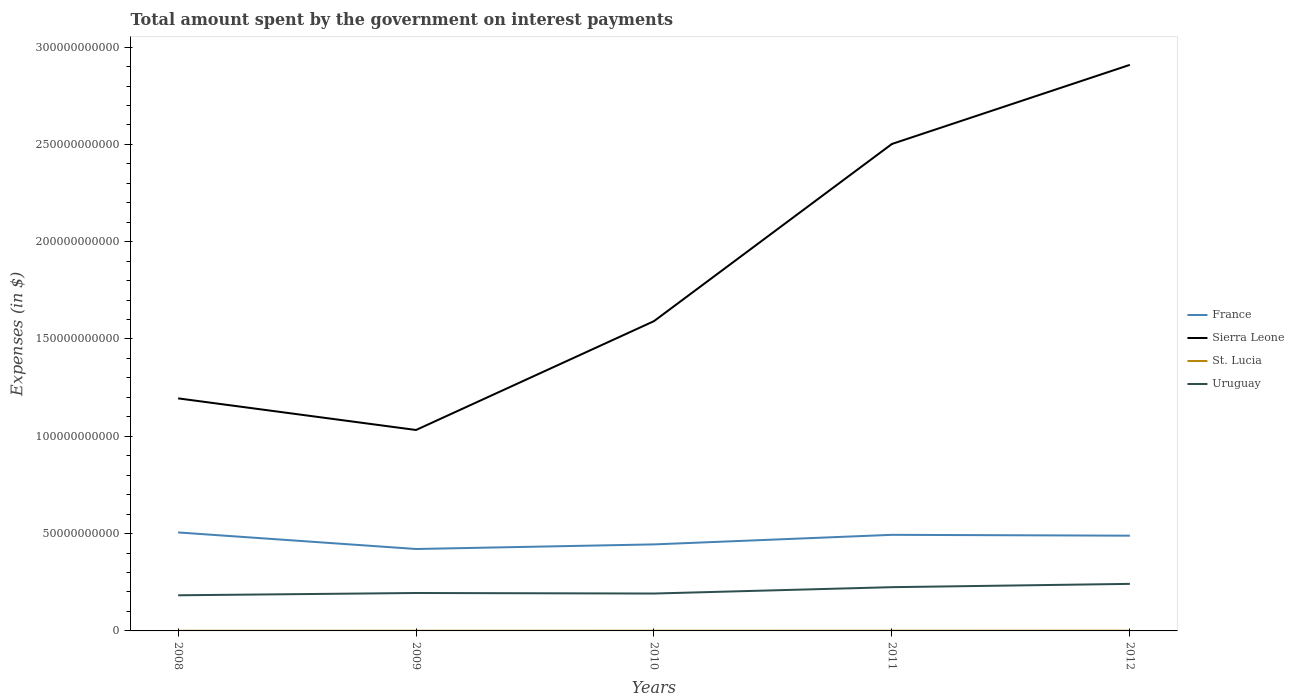Does the line corresponding to St. Lucia intersect with the line corresponding to France?
Offer a very short reply. No. Across all years, what is the maximum amount spent on interest payments by the government in St. Lucia?
Offer a terse response. 7.84e+07. What is the difference between the highest and the second highest amount spent on interest payments by the government in France?
Give a very brief answer. 8.51e+09. Is the amount spent on interest payments by the government in Sierra Leone strictly greater than the amount spent on interest payments by the government in St. Lucia over the years?
Offer a very short reply. No. Does the graph contain any zero values?
Your answer should be compact. No. How many legend labels are there?
Your response must be concise. 4. How are the legend labels stacked?
Offer a very short reply. Vertical. What is the title of the graph?
Provide a succinct answer. Total amount spent by the government on interest payments. What is the label or title of the X-axis?
Provide a short and direct response. Years. What is the label or title of the Y-axis?
Offer a very short reply. Expenses (in $). What is the Expenses (in $) in France in 2008?
Ensure brevity in your answer.  5.06e+1. What is the Expenses (in $) of Sierra Leone in 2008?
Offer a terse response. 1.19e+11. What is the Expenses (in $) in St. Lucia in 2008?
Provide a short and direct response. 7.84e+07. What is the Expenses (in $) of Uruguay in 2008?
Offer a very short reply. 1.83e+1. What is the Expenses (in $) in France in 2009?
Ensure brevity in your answer.  4.21e+1. What is the Expenses (in $) of Sierra Leone in 2009?
Your response must be concise. 1.03e+11. What is the Expenses (in $) of St. Lucia in 2009?
Your answer should be very brief. 8.98e+07. What is the Expenses (in $) in Uruguay in 2009?
Offer a terse response. 1.95e+1. What is the Expenses (in $) in France in 2010?
Make the answer very short. 4.45e+1. What is the Expenses (in $) in Sierra Leone in 2010?
Offer a terse response. 1.59e+11. What is the Expenses (in $) of St. Lucia in 2010?
Provide a short and direct response. 9.28e+07. What is the Expenses (in $) in Uruguay in 2010?
Your response must be concise. 1.92e+1. What is the Expenses (in $) of France in 2011?
Provide a succinct answer. 4.94e+1. What is the Expenses (in $) of Sierra Leone in 2011?
Offer a very short reply. 2.50e+11. What is the Expenses (in $) in St. Lucia in 2011?
Your response must be concise. 1.00e+08. What is the Expenses (in $) in Uruguay in 2011?
Your answer should be very brief. 2.25e+1. What is the Expenses (in $) in France in 2012?
Offer a very short reply. 4.89e+1. What is the Expenses (in $) in Sierra Leone in 2012?
Your response must be concise. 2.91e+11. What is the Expenses (in $) in St. Lucia in 2012?
Give a very brief answer. 1.23e+08. What is the Expenses (in $) of Uruguay in 2012?
Ensure brevity in your answer.  2.42e+1. Across all years, what is the maximum Expenses (in $) in France?
Your answer should be very brief. 5.06e+1. Across all years, what is the maximum Expenses (in $) of Sierra Leone?
Offer a very short reply. 2.91e+11. Across all years, what is the maximum Expenses (in $) in St. Lucia?
Your answer should be compact. 1.23e+08. Across all years, what is the maximum Expenses (in $) in Uruguay?
Ensure brevity in your answer.  2.42e+1. Across all years, what is the minimum Expenses (in $) of France?
Your response must be concise. 4.21e+1. Across all years, what is the minimum Expenses (in $) of Sierra Leone?
Give a very brief answer. 1.03e+11. Across all years, what is the minimum Expenses (in $) in St. Lucia?
Your answer should be very brief. 7.84e+07. Across all years, what is the minimum Expenses (in $) in Uruguay?
Give a very brief answer. 1.83e+1. What is the total Expenses (in $) in France in the graph?
Ensure brevity in your answer.  2.35e+11. What is the total Expenses (in $) of Sierra Leone in the graph?
Offer a terse response. 9.23e+11. What is the total Expenses (in $) of St. Lucia in the graph?
Provide a succinct answer. 4.84e+08. What is the total Expenses (in $) of Uruguay in the graph?
Provide a short and direct response. 1.04e+11. What is the difference between the Expenses (in $) in France in 2008 and that in 2009?
Your response must be concise. 8.51e+09. What is the difference between the Expenses (in $) of Sierra Leone in 2008 and that in 2009?
Your answer should be compact. 1.62e+1. What is the difference between the Expenses (in $) of St. Lucia in 2008 and that in 2009?
Provide a short and direct response. -1.14e+07. What is the difference between the Expenses (in $) of Uruguay in 2008 and that in 2009?
Your answer should be compact. -1.18e+09. What is the difference between the Expenses (in $) in France in 2008 and that in 2010?
Make the answer very short. 6.15e+09. What is the difference between the Expenses (in $) in Sierra Leone in 2008 and that in 2010?
Provide a short and direct response. -3.97e+1. What is the difference between the Expenses (in $) of St. Lucia in 2008 and that in 2010?
Provide a succinct answer. -1.44e+07. What is the difference between the Expenses (in $) of Uruguay in 2008 and that in 2010?
Ensure brevity in your answer.  -9.02e+08. What is the difference between the Expenses (in $) of France in 2008 and that in 2011?
Your answer should be very brief. 1.23e+09. What is the difference between the Expenses (in $) in Sierra Leone in 2008 and that in 2011?
Keep it short and to the point. -1.31e+11. What is the difference between the Expenses (in $) of St. Lucia in 2008 and that in 2011?
Offer a very short reply. -2.18e+07. What is the difference between the Expenses (in $) of Uruguay in 2008 and that in 2011?
Ensure brevity in your answer.  -4.17e+09. What is the difference between the Expenses (in $) in France in 2008 and that in 2012?
Offer a terse response. 1.66e+09. What is the difference between the Expenses (in $) of Sierra Leone in 2008 and that in 2012?
Your answer should be very brief. -1.71e+11. What is the difference between the Expenses (in $) in St. Lucia in 2008 and that in 2012?
Your response must be concise. -4.48e+07. What is the difference between the Expenses (in $) of Uruguay in 2008 and that in 2012?
Your response must be concise. -5.86e+09. What is the difference between the Expenses (in $) of France in 2009 and that in 2010?
Make the answer very short. -2.37e+09. What is the difference between the Expenses (in $) in Sierra Leone in 2009 and that in 2010?
Provide a short and direct response. -5.59e+1. What is the difference between the Expenses (in $) in Uruguay in 2009 and that in 2010?
Ensure brevity in your answer.  2.75e+08. What is the difference between the Expenses (in $) of France in 2009 and that in 2011?
Offer a terse response. -7.29e+09. What is the difference between the Expenses (in $) of Sierra Leone in 2009 and that in 2011?
Your answer should be compact. -1.47e+11. What is the difference between the Expenses (in $) of St. Lucia in 2009 and that in 2011?
Provide a short and direct response. -1.04e+07. What is the difference between the Expenses (in $) of Uruguay in 2009 and that in 2011?
Offer a terse response. -2.99e+09. What is the difference between the Expenses (in $) in France in 2009 and that in 2012?
Provide a succinct answer. -6.85e+09. What is the difference between the Expenses (in $) in Sierra Leone in 2009 and that in 2012?
Provide a succinct answer. -1.88e+11. What is the difference between the Expenses (in $) in St. Lucia in 2009 and that in 2012?
Give a very brief answer. -3.34e+07. What is the difference between the Expenses (in $) of Uruguay in 2009 and that in 2012?
Give a very brief answer. -4.69e+09. What is the difference between the Expenses (in $) in France in 2010 and that in 2011?
Your answer should be very brief. -4.92e+09. What is the difference between the Expenses (in $) in Sierra Leone in 2010 and that in 2011?
Your answer should be compact. -9.10e+1. What is the difference between the Expenses (in $) in St. Lucia in 2010 and that in 2011?
Ensure brevity in your answer.  -7.40e+06. What is the difference between the Expenses (in $) in Uruguay in 2010 and that in 2011?
Provide a short and direct response. -3.26e+09. What is the difference between the Expenses (in $) of France in 2010 and that in 2012?
Provide a succinct answer. -4.48e+09. What is the difference between the Expenses (in $) in Sierra Leone in 2010 and that in 2012?
Your response must be concise. -1.32e+11. What is the difference between the Expenses (in $) in St. Lucia in 2010 and that in 2012?
Your answer should be compact. -3.04e+07. What is the difference between the Expenses (in $) of Uruguay in 2010 and that in 2012?
Keep it short and to the point. -4.96e+09. What is the difference between the Expenses (in $) in France in 2011 and that in 2012?
Give a very brief answer. 4.36e+08. What is the difference between the Expenses (in $) of Sierra Leone in 2011 and that in 2012?
Offer a terse response. -4.06e+1. What is the difference between the Expenses (in $) in St. Lucia in 2011 and that in 2012?
Your response must be concise. -2.30e+07. What is the difference between the Expenses (in $) in Uruguay in 2011 and that in 2012?
Give a very brief answer. -1.70e+09. What is the difference between the Expenses (in $) of France in 2008 and the Expenses (in $) of Sierra Leone in 2009?
Ensure brevity in your answer.  -5.26e+1. What is the difference between the Expenses (in $) of France in 2008 and the Expenses (in $) of St. Lucia in 2009?
Keep it short and to the point. 5.05e+1. What is the difference between the Expenses (in $) in France in 2008 and the Expenses (in $) in Uruguay in 2009?
Provide a short and direct response. 3.11e+1. What is the difference between the Expenses (in $) in Sierra Leone in 2008 and the Expenses (in $) in St. Lucia in 2009?
Ensure brevity in your answer.  1.19e+11. What is the difference between the Expenses (in $) of Sierra Leone in 2008 and the Expenses (in $) of Uruguay in 2009?
Offer a very short reply. 1.00e+11. What is the difference between the Expenses (in $) in St. Lucia in 2008 and the Expenses (in $) in Uruguay in 2009?
Offer a terse response. -1.94e+1. What is the difference between the Expenses (in $) in France in 2008 and the Expenses (in $) in Sierra Leone in 2010?
Your response must be concise. -1.09e+11. What is the difference between the Expenses (in $) in France in 2008 and the Expenses (in $) in St. Lucia in 2010?
Provide a succinct answer. 5.05e+1. What is the difference between the Expenses (in $) in France in 2008 and the Expenses (in $) in Uruguay in 2010?
Ensure brevity in your answer.  3.14e+1. What is the difference between the Expenses (in $) of Sierra Leone in 2008 and the Expenses (in $) of St. Lucia in 2010?
Your response must be concise. 1.19e+11. What is the difference between the Expenses (in $) of Sierra Leone in 2008 and the Expenses (in $) of Uruguay in 2010?
Make the answer very short. 1.00e+11. What is the difference between the Expenses (in $) in St. Lucia in 2008 and the Expenses (in $) in Uruguay in 2010?
Offer a terse response. -1.91e+1. What is the difference between the Expenses (in $) in France in 2008 and the Expenses (in $) in Sierra Leone in 2011?
Offer a very short reply. -2.00e+11. What is the difference between the Expenses (in $) in France in 2008 and the Expenses (in $) in St. Lucia in 2011?
Keep it short and to the point. 5.05e+1. What is the difference between the Expenses (in $) in France in 2008 and the Expenses (in $) in Uruguay in 2011?
Keep it short and to the point. 2.81e+1. What is the difference between the Expenses (in $) of Sierra Leone in 2008 and the Expenses (in $) of St. Lucia in 2011?
Your answer should be very brief. 1.19e+11. What is the difference between the Expenses (in $) of Sierra Leone in 2008 and the Expenses (in $) of Uruguay in 2011?
Make the answer very short. 9.70e+1. What is the difference between the Expenses (in $) of St. Lucia in 2008 and the Expenses (in $) of Uruguay in 2011?
Offer a very short reply. -2.24e+1. What is the difference between the Expenses (in $) of France in 2008 and the Expenses (in $) of Sierra Leone in 2012?
Give a very brief answer. -2.40e+11. What is the difference between the Expenses (in $) in France in 2008 and the Expenses (in $) in St. Lucia in 2012?
Provide a succinct answer. 5.05e+1. What is the difference between the Expenses (in $) of France in 2008 and the Expenses (in $) of Uruguay in 2012?
Your answer should be compact. 2.64e+1. What is the difference between the Expenses (in $) in Sierra Leone in 2008 and the Expenses (in $) in St. Lucia in 2012?
Keep it short and to the point. 1.19e+11. What is the difference between the Expenses (in $) of Sierra Leone in 2008 and the Expenses (in $) of Uruguay in 2012?
Make the answer very short. 9.53e+1. What is the difference between the Expenses (in $) in St. Lucia in 2008 and the Expenses (in $) in Uruguay in 2012?
Keep it short and to the point. -2.41e+1. What is the difference between the Expenses (in $) in France in 2009 and the Expenses (in $) in Sierra Leone in 2010?
Provide a succinct answer. -1.17e+11. What is the difference between the Expenses (in $) of France in 2009 and the Expenses (in $) of St. Lucia in 2010?
Offer a terse response. 4.20e+1. What is the difference between the Expenses (in $) in France in 2009 and the Expenses (in $) in Uruguay in 2010?
Offer a very short reply. 2.29e+1. What is the difference between the Expenses (in $) in Sierra Leone in 2009 and the Expenses (in $) in St. Lucia in 2010?
Your response must be concise. 1.03e+11. What is the difference between the Expenses (in $) in Sierra Leone in 2009 and the Expenses (in $) in Uruguay in 2010?
Offer a terse response. 8.40e+1. What is the difference between the Expenses (in $) in St. Lucia in 2009 and the Expenses (in $) in Uruguay in 2010?
Provide a short and direct response. -1.91e+1. What is the difference between the Expenses (in $) in France in 2009 and the Expenses (in $) in Sierra Leone in 2011?
Provide a succinct answer. -2.08e+11. What is the difference between the Expenses (in $) in France in 2009 and the Expenses (in $) in St. Lucia in 2011?
Ensure brevity in your answer.  4.20e+1. What is the difference between the Expenses (in $) of France in 2009 and the Expenses (in $) of Uruguay in 2011?
Provide a short and direct response. 1.96e+1. What is the difference between the Expenses (in $) in Sierra Leone in 2009 and the Expenses (in $) in St. Lucia in 2011?
Your response must be concise. 1.03e+11. What is the difference between the Expenses (in $) of Sierra Leone in 2009 and the Expenses (in $) of Uruguay in 2011?
Ensure brevity in your answer.  8.08e+1. What is the difference between the Expenses (in $) of St. Lucia in 2009 and the Expenses (in $) of Uruguay in 2011?
Your answer should be very brief. -2.24e+1. What is the difference between the Expenses (in $) in France in 2009 and the Expenses (in $) in Sierra Leone in 2012?
Your response must be concise. -2.49e+11. What is the difference between the Expenses (in $) in France in 2009 and the Expenses (in $) in St. Lucia in 2012?
Provide a succinct answer. 4.20e+1. What is the difference between the Expenses (in $) of France in 2009 and the Expenses (in $) of Uruguay in 2012?
Offer a very short reply. 1.79e+1. What is the difference between the Expenses (in $) of Sierra Leone in 2009 and the Expenses (in $) of St. Lucia in 2012?
Your answer should be compact. 1.03e+11. What is the difference between the Expenses (in $) in Sierra Leone in 2009 and the Expenses (in $) in Uruguay in 2012?
Your answer should be compact. 7.91e+1. What is the difference between the Expenses (in $) in St. Lucia in 2009 and the Expenses (in $) in Uruguay in 2012?
Your answer should be compact. -2.41e+1. What is the difference between the Expenses (in $) in France in 2010 and the Expenses (in $) in Sierra Leone in 2011?
Your answer should be compact. -2.06e+11. What is the difference between the Expenses (in $) of France in 2010 and the Expenses (in $) of St. Lucia in 2011?
Your answer should be compact. 4.44e+1. What is the difference between the Expenses (in $) of France in 2010 and the Expenses (in $) of Uruguay in 2011?
Make the answer very short. 2.20e+1. What is the difference between the Expenses (in $) in Sierra Leone in 2010 and the Expenses (in $) in St. Lucia in 2011?
Your answer should be very brief. 1.59e+11. What is the difference between the Expenses (in $) in Sierra Leone in 2010 and the Expenses (in $) in Uruguay in 2011?
Your answer should be very brief. 1.37e+11. What is the difference between the Expenses (in $) of St. Lucia in 2010 and the Expenses (in $) of Uruguay in 2011?
Your answer should be very brief. -2.24e+1. What is the difference between the Expenses (in $) in France in 2010 and the Expenses (in $) in Sierra Leone in 2012?
Your response must be concise. -2.46e+11. What is the difference between the Expenses (in $) in France in 2010 and the Expenses (in $) in St. Lucia in 2012?
Offer a terse response. 4.43e+1. What is the difference between the Expenses (in $) in France in 2010 and the Expenses (in $) in Uruguay in 2012?
Offer a very short reply. 2.03e+1. What is the difference between the Expenses (in $) in Sierra Leone in 2010 and the Expenses (in $) in St. Lucia in 2012?
Make the answer very short. 1.59e+11. What is the difference between the Expenses (in $) in Sierra Leone in 2010 and the Expenses (in $) in Uruguay in 2012?
Your response must be concise. 1.35e+11. What is the difference between the Expenses (in $) in St. Lucia in 2010 and the Expenses (in $) in Uruguay in 2012?
Provide a short and direct response. -2.41e+1. What is the difference between the Expenses (in $) of France in 2011 and the Expenses (in $) of Sierra Leone in 2012?
Ensure brevity in your answer.  -2.41e+11. What is the difference between the Expenses (in $) of France in 2011 and the Expenses (in $) of St. Lucia in 2012?
Offer a terse response. 4.93e+1. What is the difference between the Expenses (in $) of France in 2011 and the Expenses (in $) of Uruguay in 2012?
Make the answer very short. 2.52e+1. What is the difference between the Expenses (in $) in Sierra Leone in 2011 and the Expenses (in $) in St. Lucia in 2012?
Provide a succinct answer. 2.50e+11. What is the difference between the Expenses (in $) of Sierra Leone in 2011 and the Expenses (in $) of Uruguay in 2012?
Offer a terse response. 2.26e+11. What is the difference between the Expenses (in $) in St. Lucia in 2011 and the Expenses (in $) in Uruguay in 2012?
Your answer should be compact. -2.41e+1. What is the average Expenses (in $) in France per year?
Your answer should be very brief. 4.71e+1. What is the average Expenses (in $) in Sierra Leone per year?
Make the answer very short. 1.85e+11. What is the average Expenses (in $) of St. Lucia per year?
Provide a short and direct response. 9.69e+07. What is the average Expenses (in $) of Uruguay per year?
Make the answer very short. 2.07e+1. In the year 2008, what is the difference between the Expenses (in $) in France and Expenses (in $) in Sierra Leone?
Offer a terse response. -6.89e+1. In the year 2008, what is the difference between the Expenses (in $) of France and Expenses (in $) of St. Lucia?
Give a very brief answer. 5.05e+1. In the year 2008, what is the difference between the Expenses (in $) of France and Expenses (in $) of Uruguay?
Your answer should be very brief. 3.23e+1. In the year 2008, what is the difference between the Expenses (in $) in Sierra Leone and Expenses (in $) in St. Lucia?
Offer a very short reply. 1.19e+11. In the year 2008, what is the difference between the Expenses (in $) in Sierra Leone and Expenses (in $) in Uruguay?
Provide a short and direct response. 1.01e+11. In the year 2008, what is the difference between the Expenses (in $) in St. Lucia and Expenses (in $) in Uruguay?
Make the answer very short. -1.82e+1. In the year 2009, what is the difference between the Expenses (in $) of France and Expenses (in $) of Sierra Leone?
Your response must be concise. -6.12e+1. In the year 2009, what is the difference between the Expenses (in $) of France and Expenses (in $) of St. Lucia?
Your answer should be compact. 4.20e+1. In the year 2009, what is the difference between the Expenses (in $) in France and Expenses (in $) in Uruguay?
Offer a very short reply. 2.26e+1. In the year 2009, what is the difference between the Expenses (in $) in Sierra Leone and Expenses (in $) in St. Lucia?
Offer a terse response. 1.03e+11. In the year 2009, what is the difference between the Expenses (in $) in Sierra Leone and Expenses (in $) in Uruguay?
Your answer should be compact. 8.38e+1. In the year 2009, what is the difference between the Expenses (in $) of St. Lucia and Expenses (in $) of Uruguay?
Make the answer very short. -1.94e+1. In the year 2010, what is the difference between the Expenses (in $) in France and Expenses (in $) in Sierra Leone?
Your answer should be compact. -1.15e+11. In the year 2010, what is the difference between the Expenses (in $) in France and Expenses (in $) in St. Lucia?
Provide a short and direct response. 4.44e+1. In the year 2010, what is the difference between the Expenses (in $) in France and Expenses (in $) in Uruguay?
Keep it short and to the point. 2.52e+1. In the year 2010, what is the difference between the Expenses (in $) in Sierra Leone and Expenses (in $) in St. Lucia?
Offer a very short reply. 1.59e+11. In the year 2010, what is the difference between the Expenses (in $) of Sierra Leone and Expenses (in $) of Uruguay?
Provide a short and direct response. 1.40e+11. In the year 2010, what is the difference between the Expenses (in $) of St. Lucia and Expenses (in $) of Uruguay?
Provide a succinct answer. -1.91e+1. In the year 2011, what is the difference between the Expenses (in $) of France and Expenses (in $) of Sierra Leone?
Offer a very short reply. -2.01e+11. In the year 2011, what is the difference between the Expenses (in $) of France and Expenses (in $) of St. Lucia?
Provide a succinct answer. 4.93e+1. In the year 2011, what is the difference between the Expenses (in $) of France and Expenses (in $) of Uruguay?
Make the answer very short. 2.69e+1. In the year 2011, what is the difference between the Expenses (in $) of Sierra Leone and Expenses (in $) of St. Lucia?
Offer a very short reply. 2.50e+11. In the year 2011, what is the difference between the Expenses (in $) in Sierra Leone and Expenses (in $) in Uruguay?
Your answer should be compact. 2.28e+11. In the year 2011, what is the difference between the Expenses (in $) of St. Lucia and Expenses (in $) of Uruguay?
Keep it short and to the point. -2.24e+1. In the year 2012, what is the difference between the Expenses (in $) in France and Expenses (in $) in Sierra Leone?
Your answer should be compact. -2.42e+11. In the year 2012, what is the difference between the Expenses (in $) of France and Expenses (in $) of St. Lucia?
Provide a short and direct response. 4.88e+1. In the year 2012, what is the difference between the Expenses (in $) of France and Expenses (in $) of Uruguay?
Provide a short and direct response. 2.48e+1. In the year 2012, what is the difference between the Expenses (in $) of Sierra Leone and Expenses (in $) of St. Lucia?
Provide a succinct answer. 2.91e+11. In the year 2012, what is the difference between the Expenses (in $) in Sierra Leone and Expenses (in $) in Uruguay?
Ensure brevity in your answer.  2.67e+11. In the year 2012, what is the difference between the Expenses (in $) in St. Lucia and Expenses (in $) in Uruguay?
Your answer should be very brief. -2.40e+1. What is the ratio of the Expenses (in $) in France in 2008 to that in 2009?
Make the answer very short. 1.2. What is the ratio of the Expenses (in $) in Sierra Leone in 2008 to that in 2009?
Give a very brief answer. 1.16. What is the ratio of the Expenses (in $) of St. Lucia in 2008 to that in 2009?
Your answer should be compact. 0.87. What is the ratio of the Expenses (in $) in Uruguay in 2008 to that in 2009?
Provide a short and direct response. 0.94. What is the ratio of the Expenses (in $) in France in 2008 to that in 2010?
Provide a short and direct response. 1.14. What is the ratio of the Expenses (in $) of Sierra Leone in 2008 to that in 2010?
Ensure brevity in your answer.  0.75. What is the ratio of the Expenses (in $) in St. Lucia in 2008 to that in 2010?
Provide a short and direct response. 0.84. What is the ratio of the Expenses (in $) in Uruguay in 2008 to that in 2010?
Make the answer very short. 0.95. What is the ratio of the Expenses (in $) of France in 2008 to that in 2011?
Your answer should be compact. 1.02. What is the ratio of the Expenses (in $) in Sierra Leone in 2008 to that in 2011?
Give a very brief answer. 0.48. What is the ratio of the Expenses (in $) in St. Lucia in 2008 to that in 2011?
Your answer should be compact. 0.78. What is the ratio of the Expenses (in $) of Uruguay in 2008 to that in 2011?
Keep it short and to the point. 0.81. What is the ratio of the Expenses (in $) of France in 2008 to that in 2012?
Your answer should be compact. 1.03. What is the ratio of the Expenses (in $) of Sierra Leone in 2008 to that in 2012?
Keep it short and to the point. 0.41. What is the ratio of the Expenses (in $) in St. Lucia in 2008 to that in 2012?
Your answer should be compact. 0.64. What is the ratio of the Expenses (in $) of Uruguay in 2008 to that in 2012?
Make the answer very short. 0.76. What is the ratio of the Expenses (in $) in France in 2009 to that in 2010?
Your answer should be very brief. 0.95. What is the ratio of the Expenses (in $) of Sierra Leone in 2009 to that in 2010?
Offer a very short reply. 0.65. What is the ratio of the Expenses (in $) in Uruguay in 2009 to that in 2010?
Provide a short and direct response. 1.01. What is the ratio of the Expenses (in $) of France in 2009 to that in 2011?
Keep it short and to the point. 0.85. What is the ratio of the Expenses (in $) in Sierra Leone in 2009 to that in 2011?
Ensure brevity in your answer.  0.41. What is the ratio of the Expenses (in $) in St. Lucia in 2009 to that in 2011?
Make the answer very short. 0.9. What is the ratio of the Expenses (in $) in Uruguay in 2009 to that in 2011?
Ensure brevity in your answer.  0.87. What is the ratio of the Expenses (in $) of France in 2009 to that in 2012?
Provide a succinct answer. 0.86. What is the ratio of the Expenses (in $) of Sierra Leone in 2009 to that in 2012?
Offer a very short reply. 0.35. What is the ratio of the Expenses (in $) of St. Lucia in 2009 to that in 2012?
Keep it short and to the point. 0.73. What is the ratio of the Expenses (in $) in Uruguay in 2009 to that in 2012?
Ensure brevity in your answer.  0.81. What is the ratio of the Expenses (in $) in France in 2010 to that in 2011?
Give a very brief answer. 0.9. What is the ratio of the Expenses (in $) of Sierra Leone in 2010 to that in 2011?
Your answer should be compact. 0.64. What is the ratio of the Expenses (in $) of St. Lucia in 2010 to that in 2011?
Give a very brief answer. 0.93. What is the ratio of the Expenses (in $) of Uruguay in 2010 to that in 2011?
Ensure brevity in your answer.  0.85. What is the ratio of the Expenses (in $) of France in 2010 to that in 2012?
Offer a terse response. 0.91. What is the ratio of the Expenses (in $) of Sierra Leone in 2010 to that in 2012?
Offer a terse response. 0.55. What is the ratio of the Expenses (in $) of St. Lucia in 2010 to that in 2012?
Provide a succinct answer. 0.75. What is the ratio of the Expenses (in $) in Uruguay in 2010 to that in 2012?
Ensure brevity in your answer.  0.79. What is the ratio of the Expenses (in $) of France in 2011 to that in 2012?
Provide a succinct answer. 1.01. What is the ratio of the Expenses (in $) of Sierra Leone in 2011 to that in 2012?
Give a very brief answer. 0.86. What is the ratio of the Expenses (in $) of St. Lucia in 2011 to that in 2012?
Give a very brief answer. 0.81. What is the ratio of the Expenses (in $) of Uruguay in 2011 to that in 2012?
Offer a terse response. 0.93. What is the difference between the highest and the second highest Expenses (in $) of France?
Give a very brief answer. 1.23e+09. What is the difference between the highest and the second highest Expenses (in $) in Sierra Leone?
Provide a succinct answer. 4.06e+1. What is the difference between the highest and the second highest Expenses (in $) in St. Lucia?
Ensure brevity in your answer.  2.30e+07. What is the difference between the highest and the second highest Expenses (in $) in Uruguay?
Your response must be concise. 1.70e+09. What is the difference between the highest and the lowest Expenses (in $) of France?
Offer a very short reply. 8.51e+09. What is the difference between the highest and the lowest Expenses (in $) of Sierra Leone?
Provide a succinct answer. 1.88e+11. What is the difference between the highest and the lowest Expenses (in $) in St. Lucia?
Keep it short and to the point. 4.48e+07. What is the difference between the highest and the lowest Expenses (in $) of Uruguay?
Give a very brief answer. 5.86e+09. 